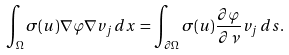<formula> <loc_0><loc_0><loc_500><loc_500>\int _ { \Omega } \sigma ( u ) \nabla \varphi \nabla v _ { j } \, d x = \int _ { \partial \Omega } \sigma ( u ) \frac { \partial \varphi } { \partial \nu } v _ { j } \, d s .</formula> 